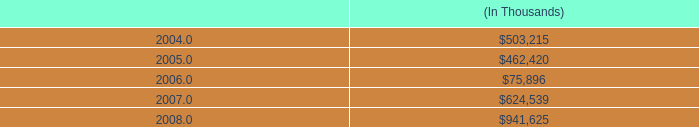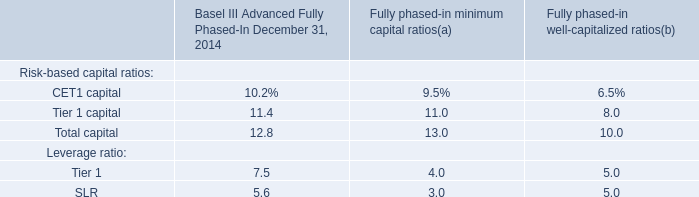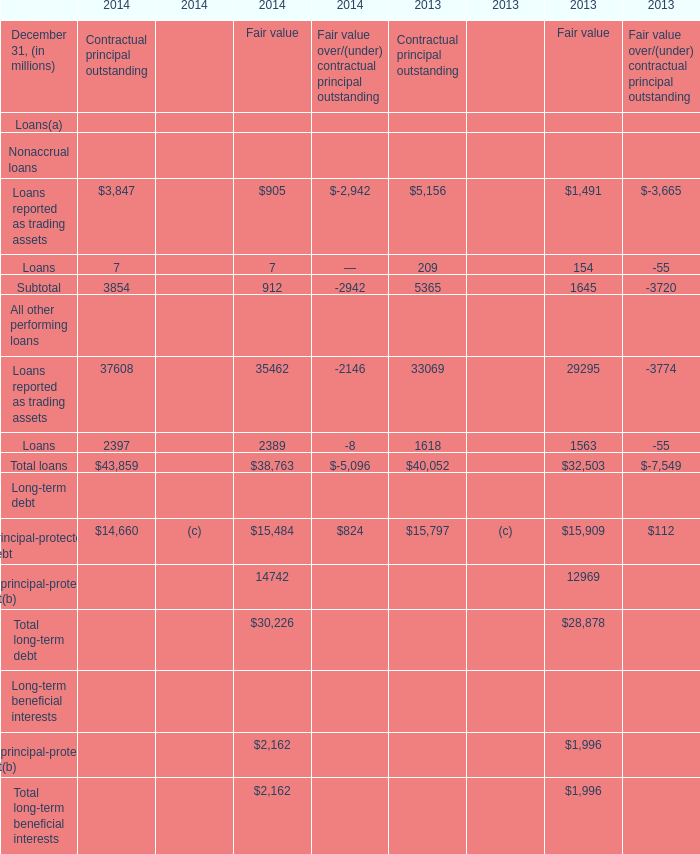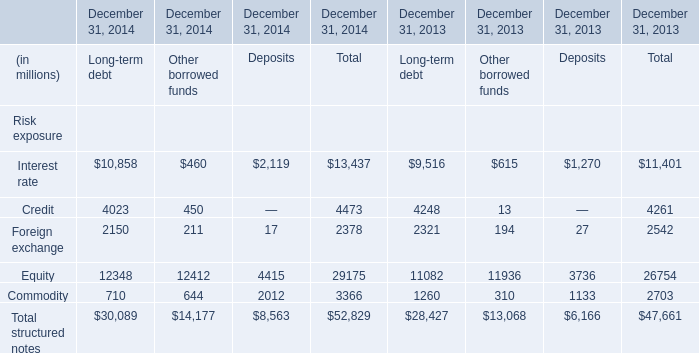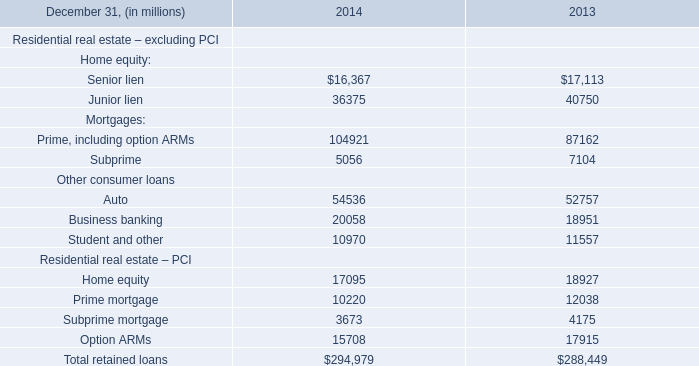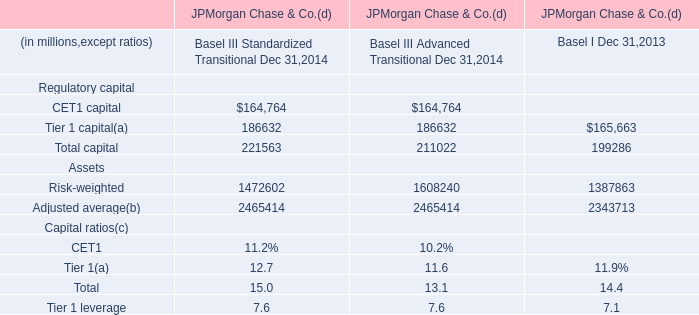How many kinds of element are greater than 40000 in 2014 for Contractual principal outstanding? 
Answer: 1. 